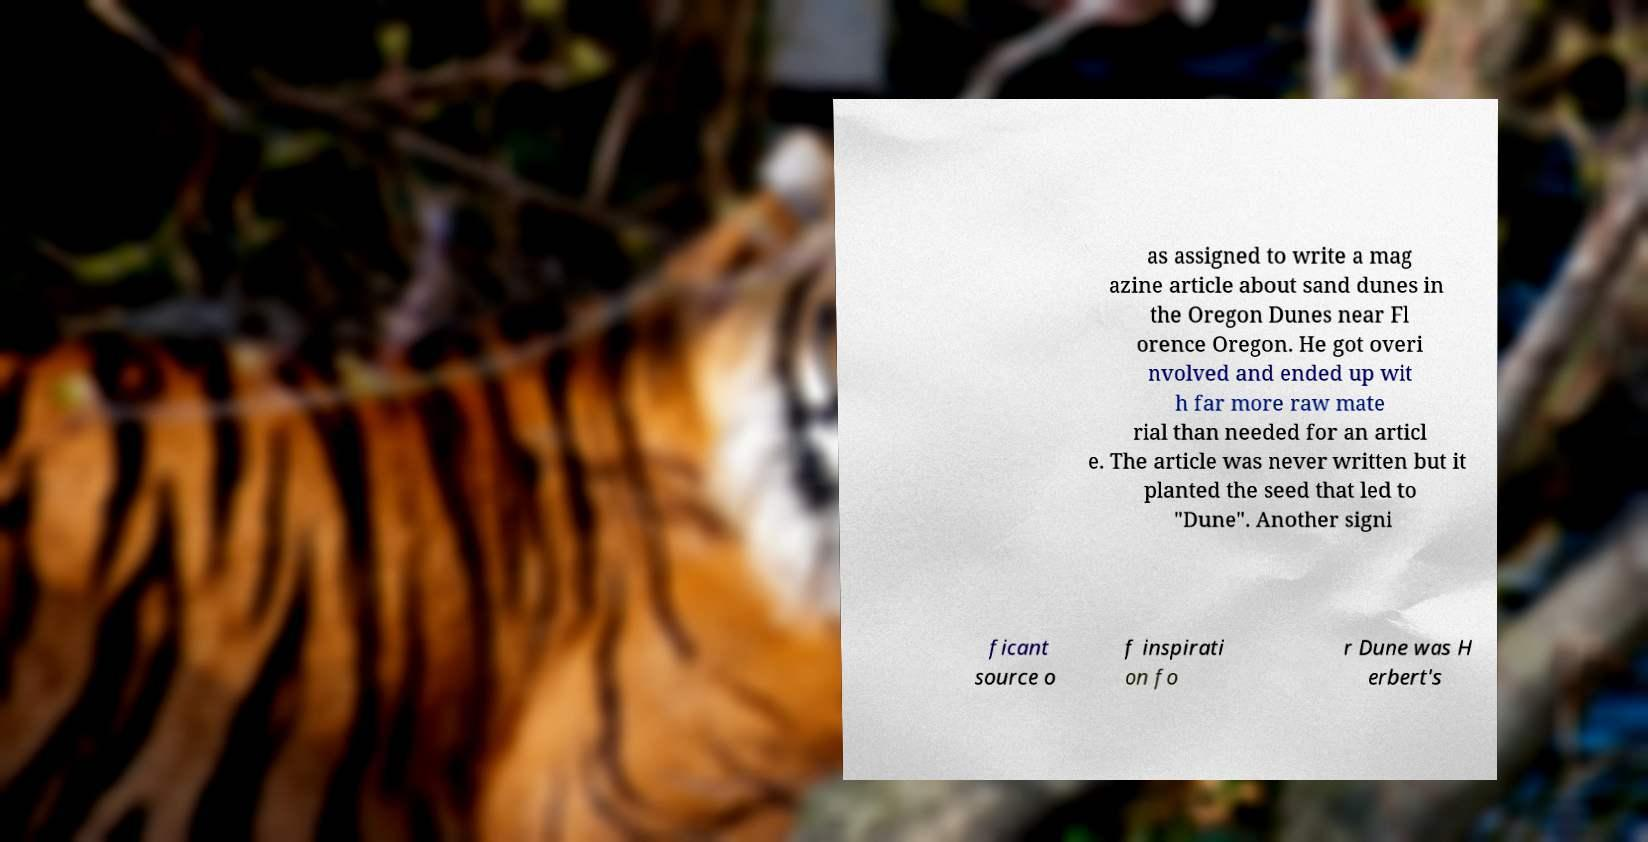I need the written content from this picture converted into text. Can you do that? as assigned to write a mag azine article about sand dunes in the Oregon Dunes near Fl orence Oregon. He got overi nvolved and ended up wit h far more raw mate rial than needed for an articl e. The article was never written but it planted the seed that led to "Dune". Another signi ficant source o f inspirati on fo r Dune was H erbert's 